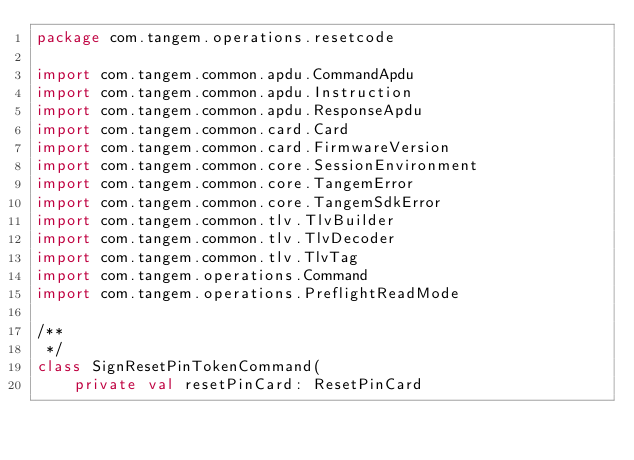<code> <loc_0><loc_0><loc_500><loc_500><_Kotlin_>package com.tangem.operations.resetcode

import com.tangem.common.apdu.CommandApdu
import com.tangem.common.apdu.Instruction
import com.tangem.common.apdu.ResponseApdu
import com.tangem.common.card.Card
import com.tangem.common.card.FirmwareVersion
import com.tangem.common.core.SessionEnvironment
import com.tangem.common.core.TangemError
import com.tangem.common.core.TangemSdkError
import com.tangem.common.tlv.TlvBuilder
import com.tangem.common.tlv.TlvDecoder
import com.tangem.common.tlv.TlvTag
import com.tangem.operations.Command
import com.tangem.operations.PreflightReadMode

/**
 */
class SignResetPinTokenCommand(
    private val resetPinCard: ResetPinCard</code> 